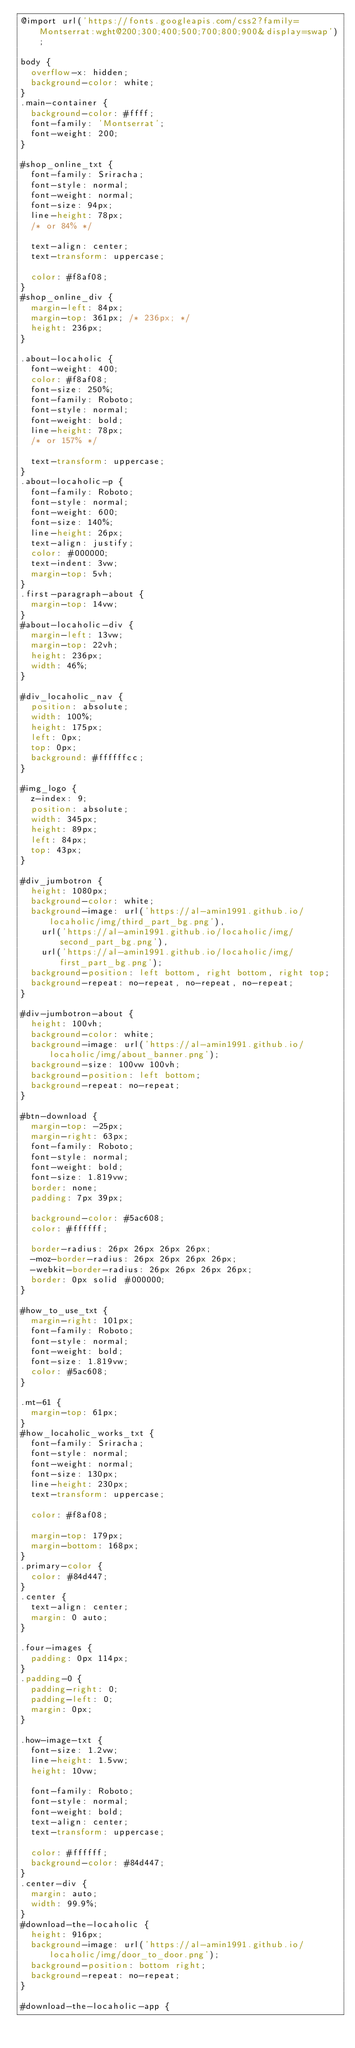<code> <loc_0><loc_0><loc_500><loc_500><_CSS_>@import url('https://fonts.googleapis.com/css2?family=Montserrat:wght@200;300;400;500;700;800;900&display=swap');

body {
  overflow-x: hidden;
  background-color: white;
}
.main-container {
  background-color: #ffff;
  font-family: 'Montserrat';
  font-weight: 200;
}

#shop_online_txt {
  font-family: Sriracha;
  font-style: normal;
  font-weight: normal;
  font-size: 94px;
  line-height: 78px;
  /* or 84% */

  text-align: center;
  text-transform: uppercase;

  color: #f8af08;
}
#shop_online_div {
  margin-left: 84px;
  margin-top: 361px; /* 236px; */
  height: 236px;
}

.about-locaholic {
  font-weight: 400;
  color: #f8af08;
  font-size: 250%;
  font-family: Roboto;
  font-style: normal;
  font-weight: bold;
  line-height: 78px;
  /* or 157% */

  text-transform: uppercase;
}
.about-locaholic-p {
  font-family: Roboto;
  font-style: normal;
  font-weight: 600;
  font-size: 140%;
  line-height: 26px;
  text-align: justify;
  color: #000000;
  text-indent: 3vw;
  margin-top: 5vh;
}
.first-paragraph-about {
  margin-top: 14vw;
}
#about-locaholic-div {
  margin-left: 13vw;
  margin-top: 22vh;
  height: 236px;
  width: 46%;
}

#div_locaholic_nav {
  position: absolute;
  width: 100%;
  height: 175px;
  left: 0px;
  top: 0px;
  background: #ffffffcc;
}

#img_logo {
  z-index: 9;
  position: absolute;
  width: 345px;
  height: 89px;
  left: 84px;
  top: 43px;
}

#div_jumbotron {
  height: 1080px;
  background-color: white;
  background-image: url('https://al-amin1991.github.io/locaholic/img/third_part_bg.png'),
    url('https://al-amin1991.github.io/locaholic/img/second_part_bg.png'),
    url('https://al-amin1991.github.io/locaholic/img/first_part_bg.png');
  background-position: left bottom, right bottom, right top;
  background-repeat: no-repeat, no-repeat, no-repeat;
}

#div-jumbotron-about {
  height: 100vh;
  background-color: white;
  background-image: url('https://al-amin1991.github.io/locaholic/img/about_banner.png');
  background-size: 100vw 100vh;
  background-position: left bottom;
  background-repeat: no-repeat;
}

#btn-download {
  margin-top: -25px;
  margin-right: 63px;
  font-family: Roboto;
  font-style: normal;
  font-weight: bold;
  font-size: 1.819vw;
  border: none;
  padding: 7px 39px;

  background-color: #5ac608;
  color: #ffffff;

  border-radius: 26px 26px 26px 26px;
  -moz-border-radius: 26px 26px 26px 26px;
  -webkit-border-radius: 26px 26px 26px 26px;
  border: 0px solid #000000;
}

#how_to_use_txt {
  margin-right: 101px;
  font-family: Roboto;
  font-style: normal;
  font-weight: bold;
  font-size: 1.819vw;
  color: #5ac608;
}

.mt-61 {
  margin-top: 61px;
}
#how_locaholic_works_txt {
  font-family: Sriracha;
  font-style: normal;
  font-weight: normal;
  font-size: 130px;
  line-height: 230px;
  text-transform: uppercase;

  color: #f8af08;

  margin-top: 179px;
  margin-bottom: 168px;
}
.primary-color {
  color: #84d447;
}
.center {
  text-align: center;
  margin: 0 auto;
}

.four-images {
  padding: 0px 114px;
}
.padding-0 {
  padding-right: 0;
  padding-left: 0;
  margin: 0px;
}

.how-image-txt {
  font-size: 1.2vw;
  line-height: 1.5vw;
  height: 10vw;

  font-family: Roboto;
  font-style: normal;
  font-weight: bold;
  text-align: center;
  text-transform: uppercase;

  color: #ffffff;
  background-color: #84d447;
}
.center-div {
  margin: auto;
  width: 99.9%;
}
#download-the-locaholic {
  height: 916px;
  background-image: url('https://al-amin1991.github.io/locaholic/img/door_to_door.png');
  background-position: bottom right;
  background-repeat: no-repeat;
}

#download-the-locaholic-app {</code> 